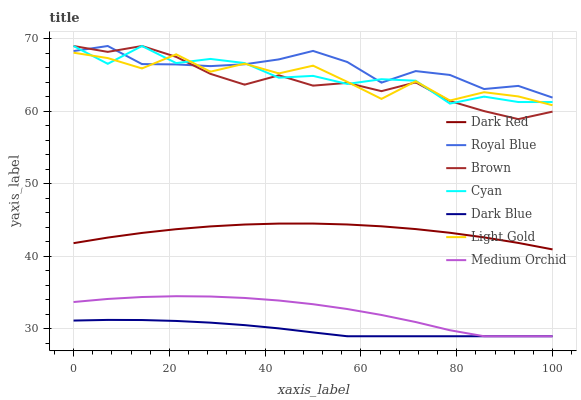Does Dark Blue have the minimum area under the curve?
Answer yes or no. Yes. Does Royal Blue have the maximum area under the curve?
Answer yes or no. Yes. Does Dark Red have the minimum area under the curve?
Answer yes or no. No. Does Dark Red have the maximum area under the curve?
Answer yes or no. No. Is Dark Blue the smoothest?
Answer yes or no. Yes. Is Light Gold the roughest?
Answer yes or no. Yes. Is Royal Blue the smoothest?
Answer yes or no. No. Is Royal Blue the roughest?
Answer yes or no. No. Does Medium Orchid have the lowest value?
Answer yes or no. Yes. Does Dark Red have the lowest value?
Answer yes or no. No. Does Cyan have the highest value?
Answer yes or no. Yes. Does Dark Red have the highest value?
Answer yes or no. No. Is Dark Blue less than Cyan?
Answer yes or no. Yes. Is Royal Blue greater than Dark Blue?
Answer yes or no. Yes. Does Light Gold intersect Brown?
Answer yes or no. Yes. Is Light Gold less than Brown?
Answer yes or no. No. Is Light Gold greater than Brown?
Answer yes or no. No. Does Dark Blue intersect Cyan?
Answer yes or no. No. 